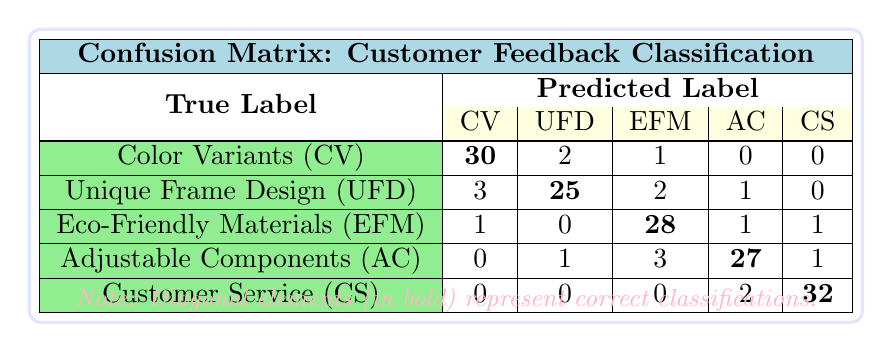What is the total number of predictions made for the "Unique Frame Design"? To find the total predictions for "Unique Frame Design," look at the second row of the confusion matrix. Summing all the values in that row gives us 3 (Color Variants) + 25 (Unique Frame Design) + 2 (Eco-Friendly Materials) + 1 (Adjustable Components) + 0 (Customer Service) = 31.
Answer: 31 How many customers gave feedback on "Eco-Friendly Materials" that was incorrectly classified? To find the incorrectly classified feedback for "Eco-Friendly Materials," we look at the third row, which lists predictions for this feature. The incorrectly classified counts are 1 (Color Variants), 0 (Unique Frame Design), and 1 (Adjustable Components), which sums up to 1 + 0 + 1 = 2.
Answer: 2 What percentage of the predictions for "Customer Service" were correct? To find this percentage, identify the correct predictions from the "Customer Service" row, which is the value of the bold cell (32). The total predictions made for "Customer Service" is 0 + 0 + 0 + 2 + 32 = 34. Therefore, the percentage of correct predictions is (32 / 34) * 100 ≈ 94.12%.
Answer: 94.12% Is it true that "Color Variants" had more correct predictions than "Unique Frame Design"? Looking at the confusion matrix, the correct predictions for "Color Variants" are 30, and for "Unique Frame Design," it is 25. Since 30 is greater than 25, the statement is true.
Answer: Yes Which feature had the highest sum of incorrectly classified feedback? To find this, we check each row for "incorrect" feedback counts. For "Color Variants," the incorrectly classified counts are 2 + 1 + 0 + 0 = 3. For "Unique Frame Design," it's 3 + 2 + 1 = 6. For "Eco-Friendly Materials," it's 1 + 0 + 1 = 2. For "Adjustable Components," it's 1 + 3 + 1 = 5. For "Customer Service," it's 0 + 0 + 0 + 2 = 2. The highest sum occurs for "Unique Frame Design," which totals to 6.
Answer: Unique Frame Design How many predictions were completely accurate across all features? A prediction is completely accurate across all features if all the labeled counts in the diagonal elements of the confusion matrix are considered. The diagonal counts are 30 (Color Variants), 25 (Unique Frame Design), 28 (Eco-Friendly Materials), 27 (Adjustable Components), and 32 (Customer Service). Therefore, the total accurate predictions are 30 + 25 + 28 + 27 + 32 = 142.
Answer: 142 